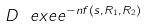<formula> <loc_0><loc_0><loc_500><loc_500>D \ e x e e ^ { - n f ( s , R _ { 1 } , R _ { 2 } ) }</formula> 